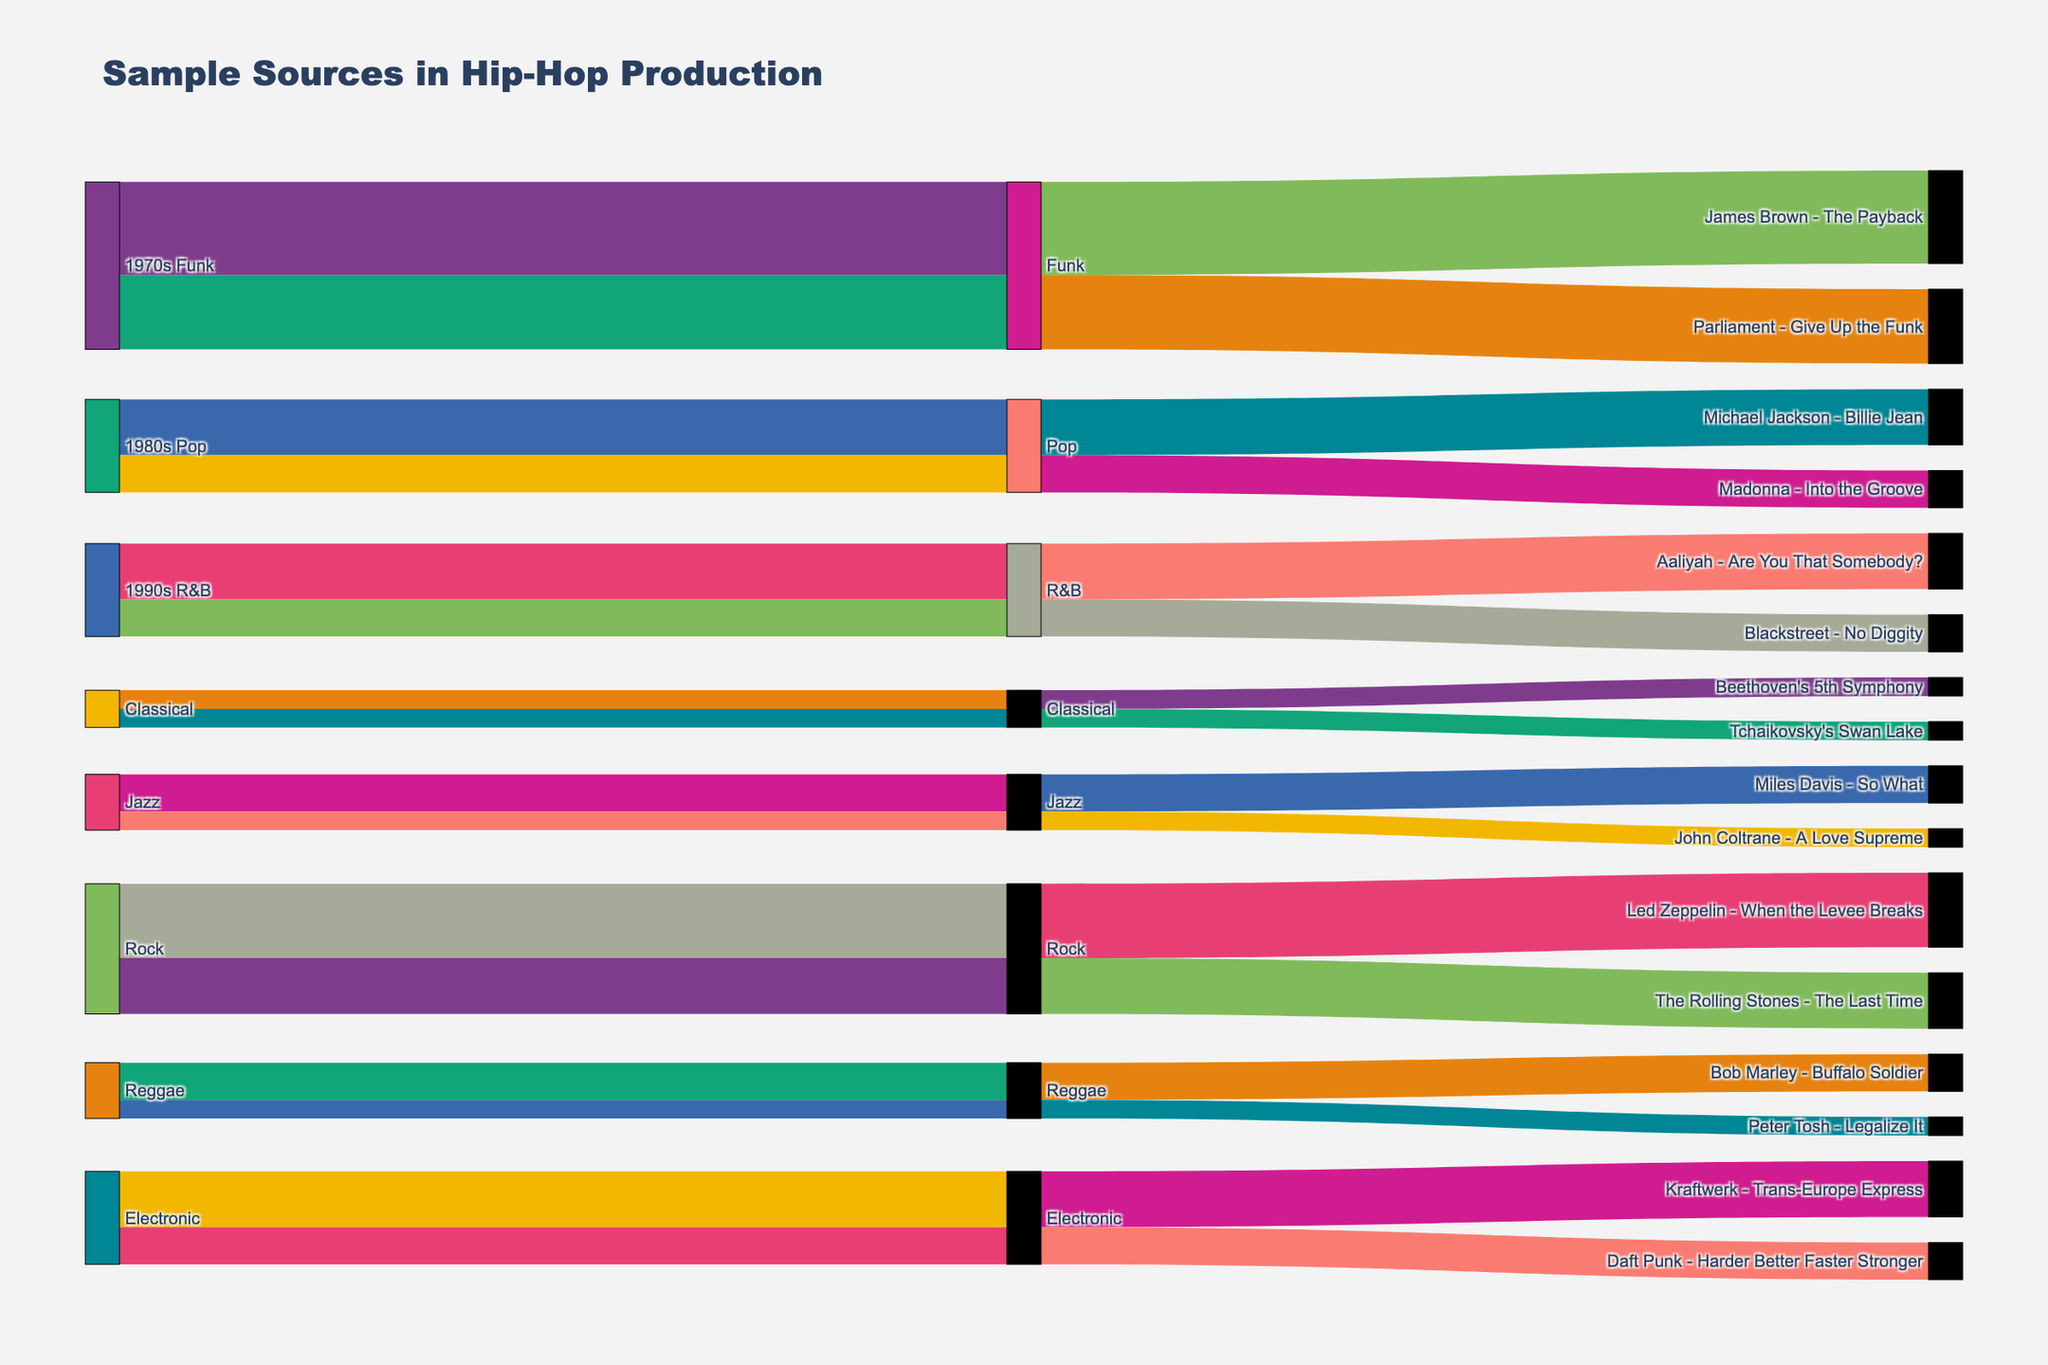What is the title of the diagram? The title can often be found at the top of the diagram. In this case, it reads "Sample Sources in Hip-Hop Production".
Answer: Sample Sources in Hip-Hop Production How many unique sample sources are shown in the diagram? By looking at the source labels, we can count the unique sources, which include: 1970s Funk, 1980s Pop, 1990s R&B, Classical, Jazz, Rock, Reggae, and Electronic.
Answer: 8 Which sample source has the highest number of samples used in hip-hop production? By examining the width of the bars connecting to various genres, we see that '1970s Funk', connecting to multiple genres with the highest total usage counts.
Answer: 1970s Funk How many total samples come from the 1980s Pop source? The samples 'Michael Jackson - Billie Jean' and 'Madonna - Into the Groove' connected to the '1980s Pop' source have usage counts of 3 and 2, respectively, adding up to 5.
Answer: 5 What genre used the song 'Miles Davis - So What' as a sample, and how many times? 'Miles Davis - So What' is examined, and we find it's connected to the Jazz genre with a usage count of 2.
Answer: Jazz, 2 Among the genres, which one utilizes the most diverse range of sample sources? To determine this, count the number of different sources connecting to each genre. The genre 'Funk' connects to the most sources.
Answer: Funk How many samples come from the Classical genre, and which compositions are they? The Classical genre includes two samples: 'Beethoven's 5th Symphony' and 'Tchaikovsky's Swan Lake', each used once, making a total of 2.
Answer: 2, 'Beethoven's 5th Symphony' and 'Tchaikovsky's Swan Lake' How many more samples are there from Rock compared to Reggae? Rock samples include 'Led Zeppelin - When the Levee Breaks' (4) and 'The Rolling Stones - The Last Time' (3) totaling 7. Reggae includes 'Bob Marley - Buffalo Soldier' (2) and 'Peter Tosh - Legalize It' (1), totaling 3. The difference is 7 - 3 = 4.
Answer: 4 Which specific sample is used the most overall, and from which source does it come? By examining the usage counts next to each sample, 'James Brown - The Payback' from the 1970s Funk source has the highest count with 5.
Answer: 'James Brown - The Payback', 1970s Funk 